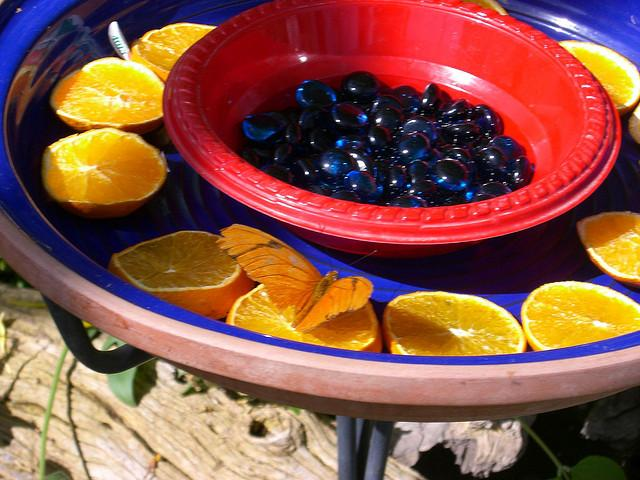What color are the beads inside of the red bowl? blue 